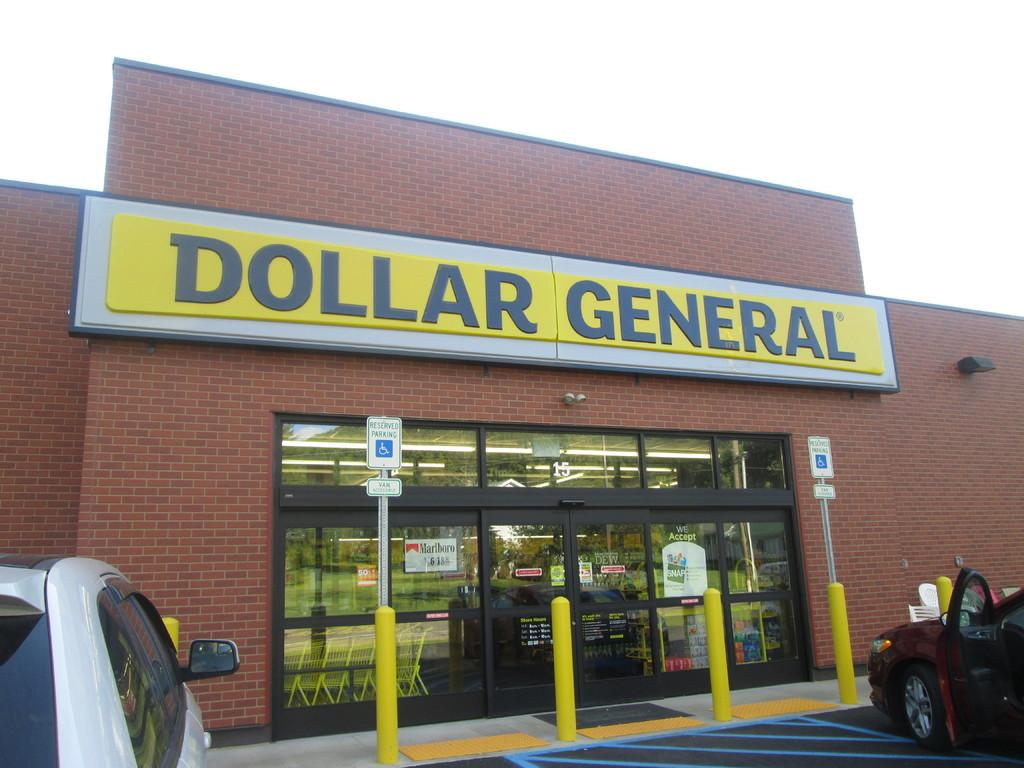What type of establishment is visible in the image? There is a store in the image. How many cars are parked near the store? Two cars are parked in front of the store. Where are the cars located in relation to the store? The cars are on a road in front of the store. What material is used to construct the wall of the store? The wall of the store is made of bricks. How long does it take for the minute hand to complete one rotation on the store's clock in the image? There is no clock visible in the image, so it is impossible to determine how long it takes for the minute hand to complete one rotation. 